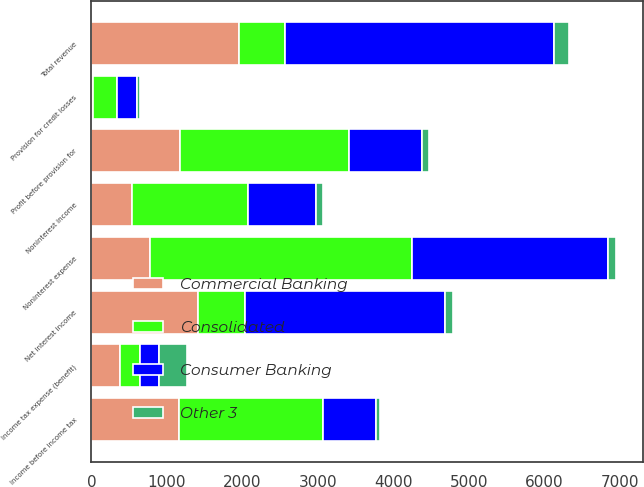Convert chart to OTSL. <chart><loc_0><loc_0><loc_500><loc_500><stacked_bar_chart><ecel><fcel>Net interest income<fcel>Noninterest income<fcel>Total revenue<fcel>Noninterest expense<fcel>Profit before provision for<fcel>Provision for credit losses<fcel>Income before income tax<fcel>Income tax expense (benefit)<nl><fcel>Consumer Banking<fcel>2651<fcel>905<fcel>3556<fcel>2593<fcel>963<fcel>265<fcel>698<fcel>246<nl><fcel>Commercial Banking<fcel>1411<fcel>538<fcel>1949<fcel>772<fcel>1177<fcel>19<fcel>1158<fcel>384<nl><fcel>Other 3<fcel>111<fcel>91<fcel>202<fcel>109<fcel>93<fcel>37<fcel>56<fcel>370<nl><fcel>Consolidated<fcel>618<fcel>1534<fcel>618<fcel>3474<fcel>2233<fcel>321<fcel>1912<fcel>260<nl></chart> 